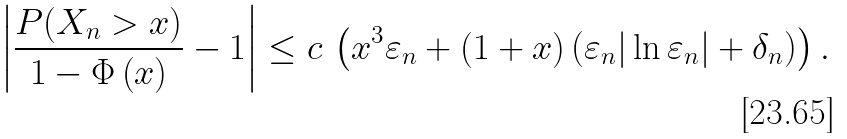Convert formula to latex. <formula><loc_0><loc_0><loc_500><loc_500>\left | \frac { P ( X _ { n } > x ) } { 1 - \Phi \left ( x \right ) } - 1 \right | \leq c \, \left ( x ^ { 3 } \varepsilon _ { n } + ( 1 + x ) \left ( \varepsilon _ { n } | \ln \varepsilon _ { n } | + \delta _ { n } \right ) \right ) .</formula> 